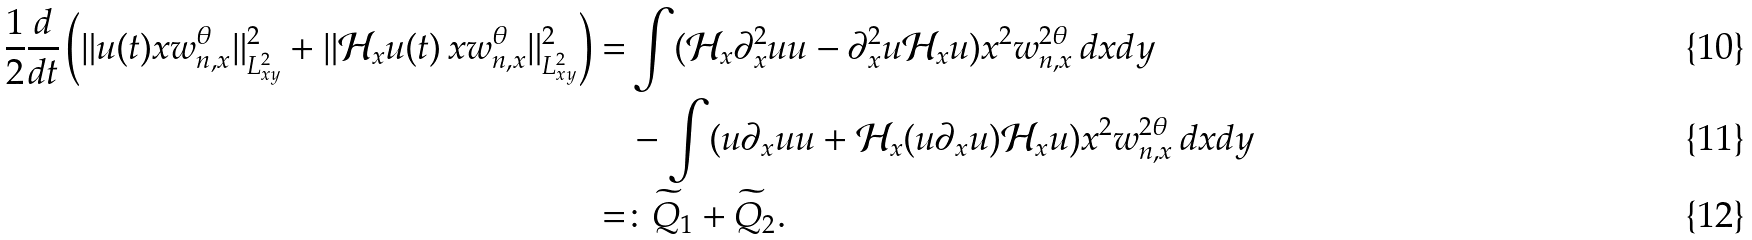Convert formula to latex. <formula><loc_0><loc_0><loc_500><loc_500>\frac { 1 } { 2 } \frac { d } { d t } \left ( \| u ( t ) x w ^ { \theta } _ { n , x } \| _ { L ^ { 2 } _ { x y } } ^ { 2 } + \| \mathcal { H } _ { x } u ( t ) \, x w ^ { \theta } _ { n , x } \| _ { L ^ { 2 } _ { x y } } ^ { 2 } \right ) = & \int ( \mathcal { H } _ { x } \partial _ { x } ^ { 2 } u u - \partial _ { x } ^ { 2 } u \mathcal { H } _ { x } u ) x ^ { 2 } w _ { n , x } ^ { 2 \theta } \, d x d y \\ & - \int ( u \partial _ { x } u u + \mathcal { H } _ { x } ( u \partial _ { x } u ) \mathcal { H } _ { x } u ) x ^ { 2 } w _ { n , x } ^ { 2 \theta } \, d x d y \\ = & \colon \widetilde { Q } _ { 1 } + \widetilde { Q } _ { 2 } .</formula> 